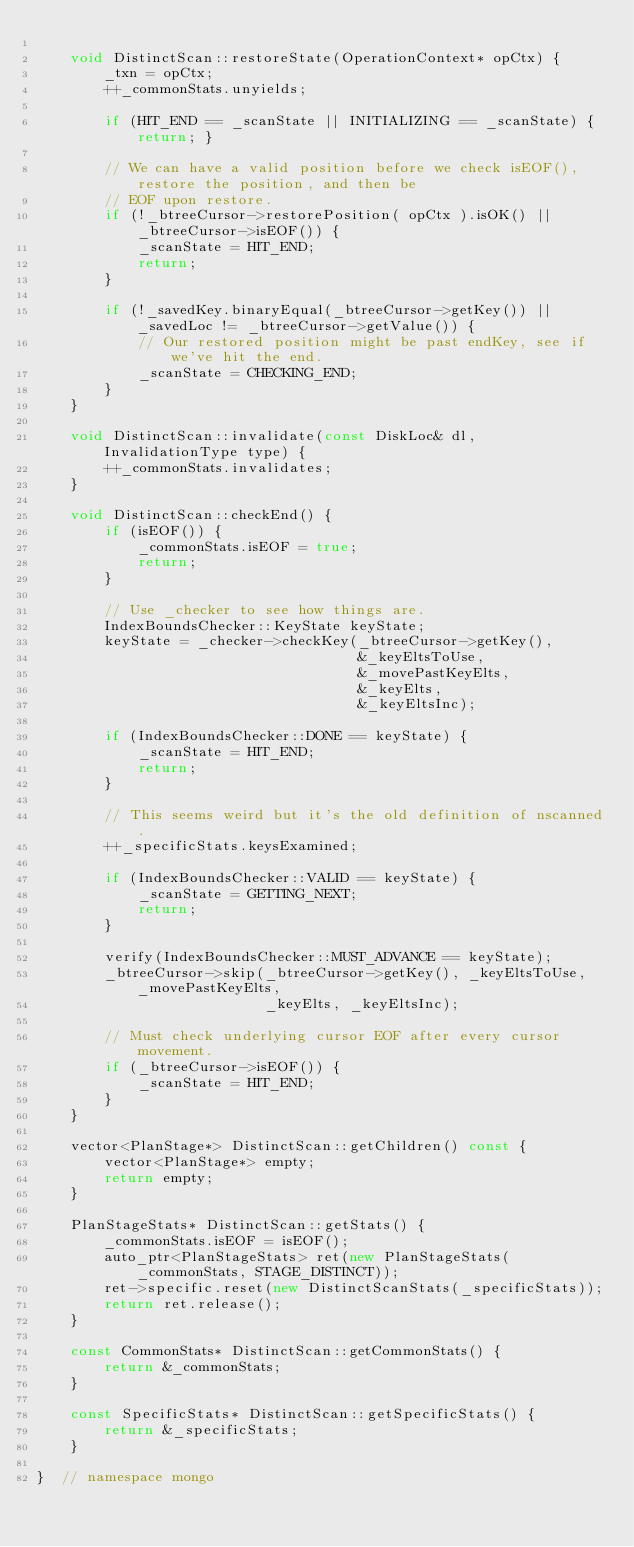<code> <loc_0><loc_0><loc_500><loc_500><_C++_>
    void DistinctScan::restoreState(OperationContext* opCtx) {
        _txn = opCtx;
        ++_commonStats.unyields;

        if (HIT_END == _scanState || INITIALIZING == _scanState) { return; }

        // We can have a valid position before we check isEOF(), restore the position, and then be
        // EOF upon restore.
        if (!_btreeCursor->restorePosition( opCtx ).isOK() || _btreeCursor->isEOF()) {
            _scanState = HIT_END;
            return;
        }

        if (!_savedKey.binaryEqual(_btreeCursor->getKey()) || _savedLoc != _btreeCursor->getValue()) {
            // Our restored position might be past endKey, see if we've hit the end.
            _scanState = CHECKING_END;
        }
    }

    void DistinctScan::invalidate(const DiskLoc& dl, InvalidationType type) {
        ++_commonStats.invalidates;
    }

    void DistinctScan::checkEnd() {
        if (isEOF()) {
            _commonStats.isEOF = true;
            return;
        }

        // Use _checker to see how things are.
        IndexBoundsChecker::KeyState keyState;
        keyState = _checker->checkKey(_btreeCursor->getKey(),
                                      &_keyEltsToUse,
                                      &_movePastKeyElts,
                                      &_keyElts,
                                      &_keyEltsInc);

        if (IndexBoundsChecker::DONE == keyState) {
            _scanState = HIT_END;
            return;
        }

        // This seems weird but it's the old definition of nscanned.
        ++_specificStats.keysExamined;

        if (IndexBoundsChecker::VALID == keyState) {
            _scanState = GETTING_NEXT;
            return;
        }

        verify(IndexBoundsChecker::MUST_ADVANCE == keyState);
        _btreeCursor->skip(_btreeCursor->getKey(), _keyEltsToUse, _movePastKeyElts,
                           _keyElts, _keyEltsInc);

        // Must check underlying cursor EOF after every cursor movement.
        if (_btreeCursor->isEOF()) {
            _scanState = HIT_END;
        }
    }

    vector<PlanStage*> DistinctScan::getChildren() const {
        vector<PlanStage*> empty;
        return empty;
    }

    PlanStageStats* DistinctScan::getStats() {
        _commonStats.isEOF = isEOF();
        auto_ptr<PlanStageStats> ret(new PlanStageStats(_commonStats, STAGE_DISTINCT));
        ret->specific.reset(new DistinctScanStats(_specificStats));
        return ret.release();
    }

    const CommonStats* DistinctScan::getCommonStats() {
        return &_commonStats;
    }

    const SpecificStats* DistinctScan::getSpecificStats() {
        return &_specificStats;
    }

}  // namespace mongo
</code> 